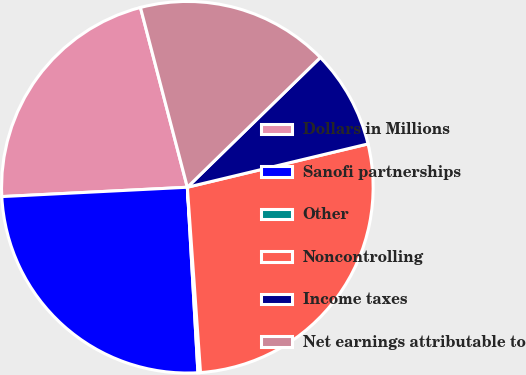<chart> <loc_0><loc_0><loc_500><loc_500><pie_chart><fcel>Dollars in Millions<fcel>Sanofi partnerships<fcel>Other<fcel>Noncontrolling<fcel>Income taxes<fcel>Net earnings attributable to<nl><fcel>21.74%<fcel>25.11%<fcel>0.22%<fcel>27.62%<fcel>8.56%<fcel>16.76%<nl></chart> 